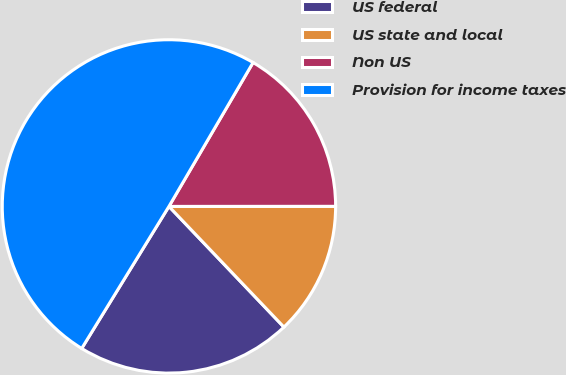Convert chart to OTSL. <chart><loc_0><loc_0><loc_500><loc_500><pie_chart><fcel>US federal<fcel>US state and local<fcel>Non US<fcel>Provision for income taxes<nl><fcel>20.88%<fcel>12.89%<fcel>16.57%<fcel>49.65%<nl></chart> 